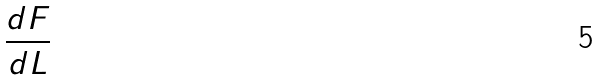<formula> <loc_0><loc_0><loc_500><loc_500>\frac { d F } { d L }</formula> 